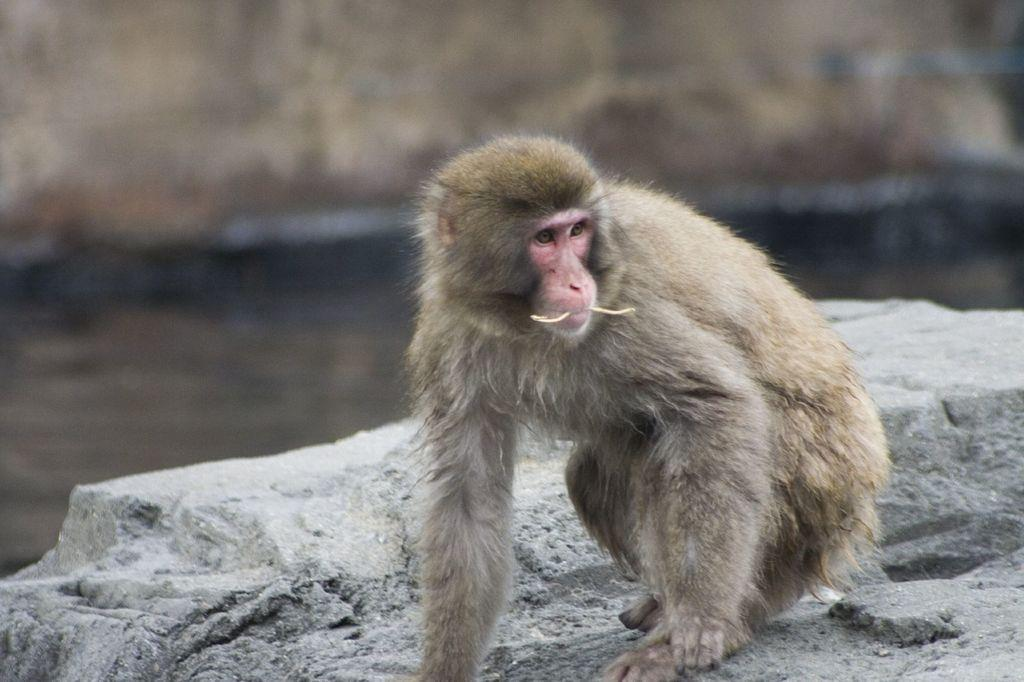What type of animal is in the image? There is a monkey in the image. What other object can be seen in the image? There is a rock in the image. Where is the rabbit in the image? There is no rabbit present in the image. What advice does the father give to the monkey in the image? There is no father or any indication of advice-giving in the image; it only features a monkey and a rock. 